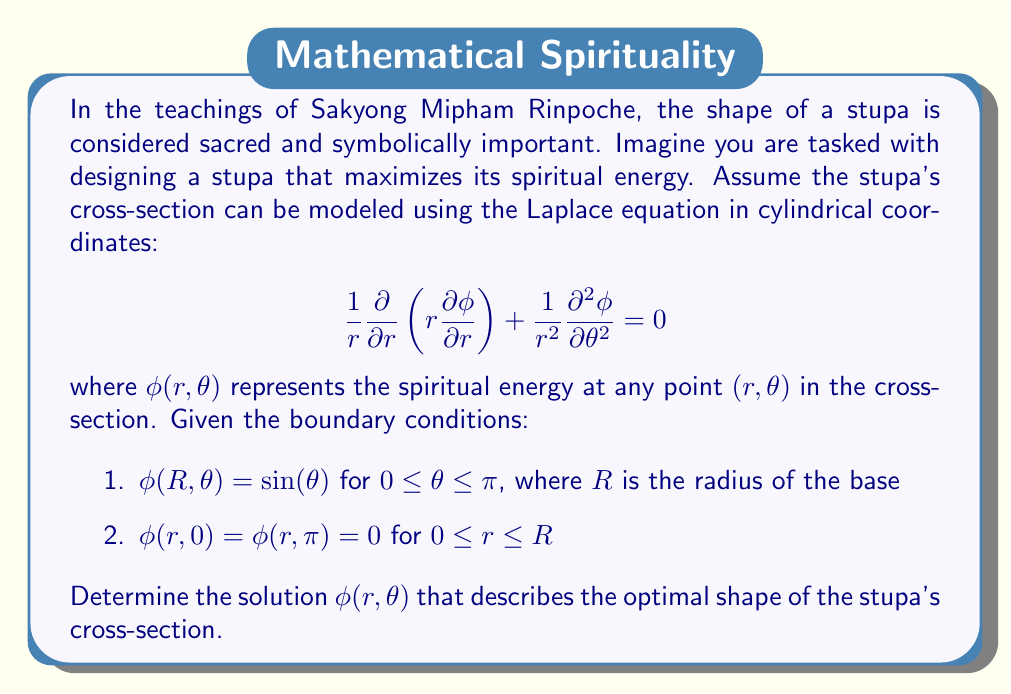Can you solve this math problem? To solve this problem, we'll use the method of separation of variables. Let's approach this step-by-step:

1) Assume the solution has the form $\phi(r,\theta) = R(r)\Theta(\theta)$.

2) Substituting this into the Laplace equation:

   $$\frac{1}{r}\frac{1}{R}\frac{d}{dr}\left(r\frac{dR}{dr}\right) + \frac{1}{r^2}\frac{1}{\Theta}\frac{d^2\Theta}{d\theta^2} = 0$$

3) Separating variables:

   $$r\frac{1}{R}\frac{d}{dr}\left(r\frac{dR}{dr}\right) = -\frac{1}{\Theta}\frac{d^2\Theta}{d\theta^2} = \lambda^2$$

   where $\lambda^2$ is the separation constant.

4) For the $\theta$ equation:
   
   $$\frac{d^2\Theta}{d\theta^2} + \lambda^2\Theta = 0$$

   The general solution is $\Theta(\theta) = A\sin(\lambda\theta) + B\cos(\lambda\theta)$.

5) Using the boundary conditions $\phi(r,0) = \phi(r,\pi) = 0$, we get $B = 0$ and $\lambda = n$ where $n$ is a positive integer.

6) For the $r$ equation:

   $$r\frac{d}{dr}\left(r\frac{dR}{dr}\right) - n^2R = 0$$

   This is Euler's equation with general solution $R(r) = Cr^n + Dr^{-n}$.

7) The complete solution is:

   $$\phi(r,\theta) = \sum_{n=1}^{\infty} (A_nr^n + B_nr^{-n})\sin(n\theta)$$

8) Using the boundary condition $\phi(R,\theta) = \sin(\theta)$, we can determine that only $n = 1$ is needed, and:

   $$A_1R + B_1R^{-1} = 1$$
   $$A_1R^2 + B_1 = R$$

9) Solving these equations:

   $$A_1 = \frac{1}{R}, B_1 = 0$$

Therefore, the final solution is:

$$\phi(r,\theta) = \frac{r}{R}\sin(\theta)$$

This solution represents the optimal shape of the stupa's cross-section that maximizes its spiritual energy according to the given model.
Answer: $$\phi(r,\theta) = \frac{r}{R}\sin(\theta)$$ 